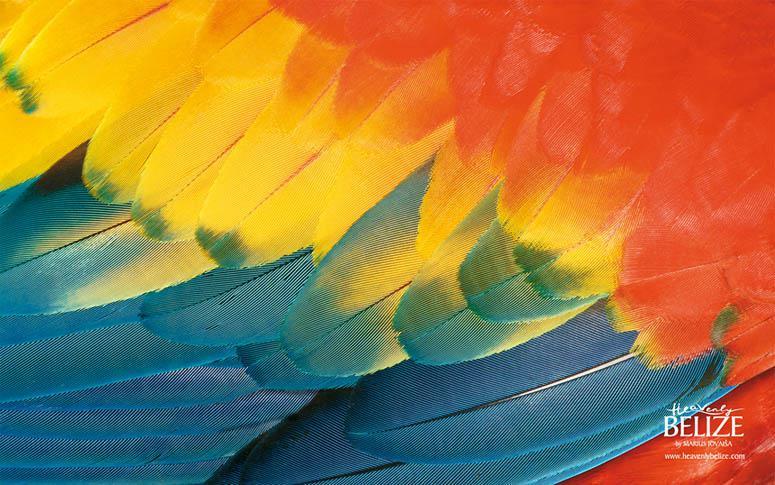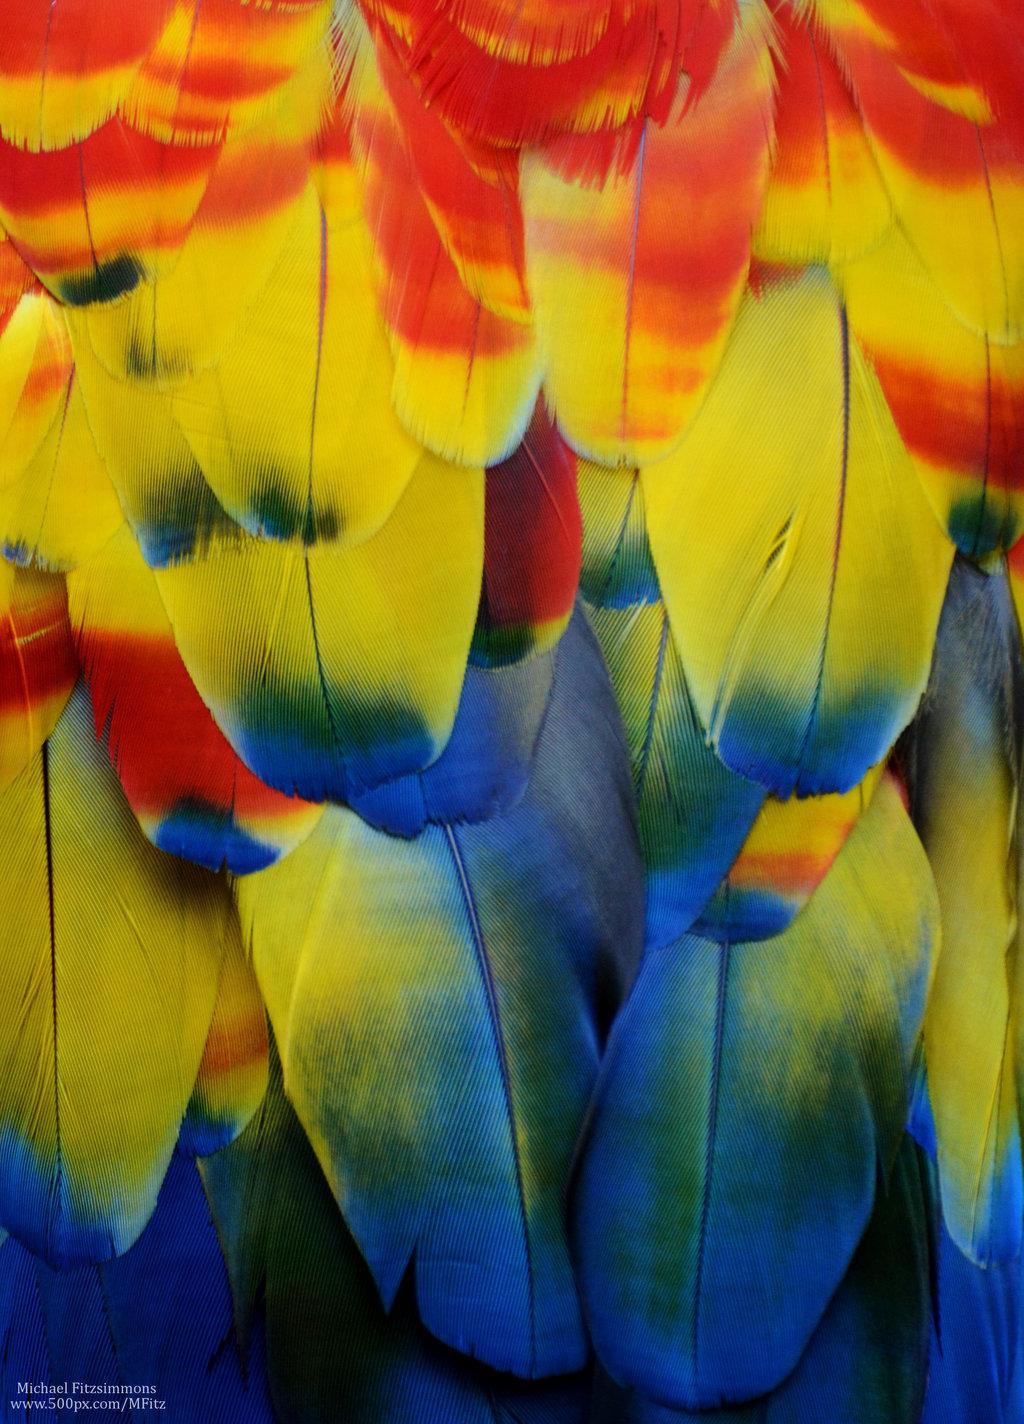The first image is the image on the left, the second image is the image on the right. Considering the images on both sides, is "You can see a Macaw's beak in the left image." valid? Answer yes or no. No. The first image is the image on the left, the second image is the image on the right. Analyze the images presented: Is the assertion "Atleast one photo has 2 birds" valid? Answer yes or no. No. 